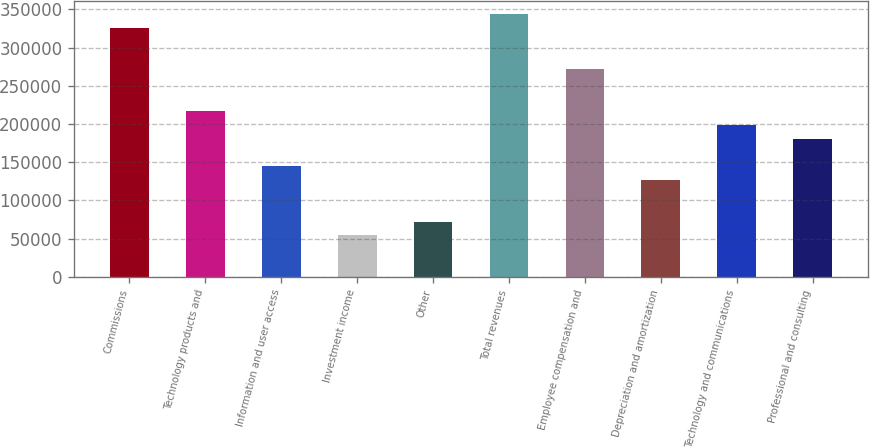Convert chart. <chart><loc_0><loc_0><loc_500><loc_500><bar_chart><fcel>Commissions<fcel>Technology products and<fcel>Information and user access<fcel>Investment income<fcel>Other<fcel>Total revenues<fcel>Employee compensation and<fcel>Depreciation and amortization<fcel>Technology and communications<fcel>Professional and consulting<nl><fcel>325978<fcel>217319<fcel>144879<fcel>54329.9<fcel>72439.8<fcel>344088<fcel>271648<fcel>126769<fcel>199209<fcel>181099<nl></chart> 